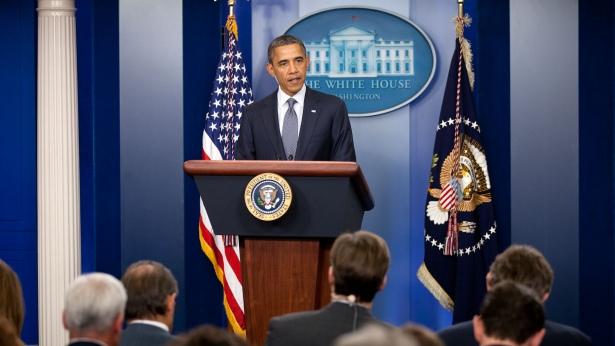Is this a press conference?
Keep it brief. Yes. What is the name of the president?
Answer briefly. Barack obama. How many stars on are on the flags?
Be succinct. 50. 